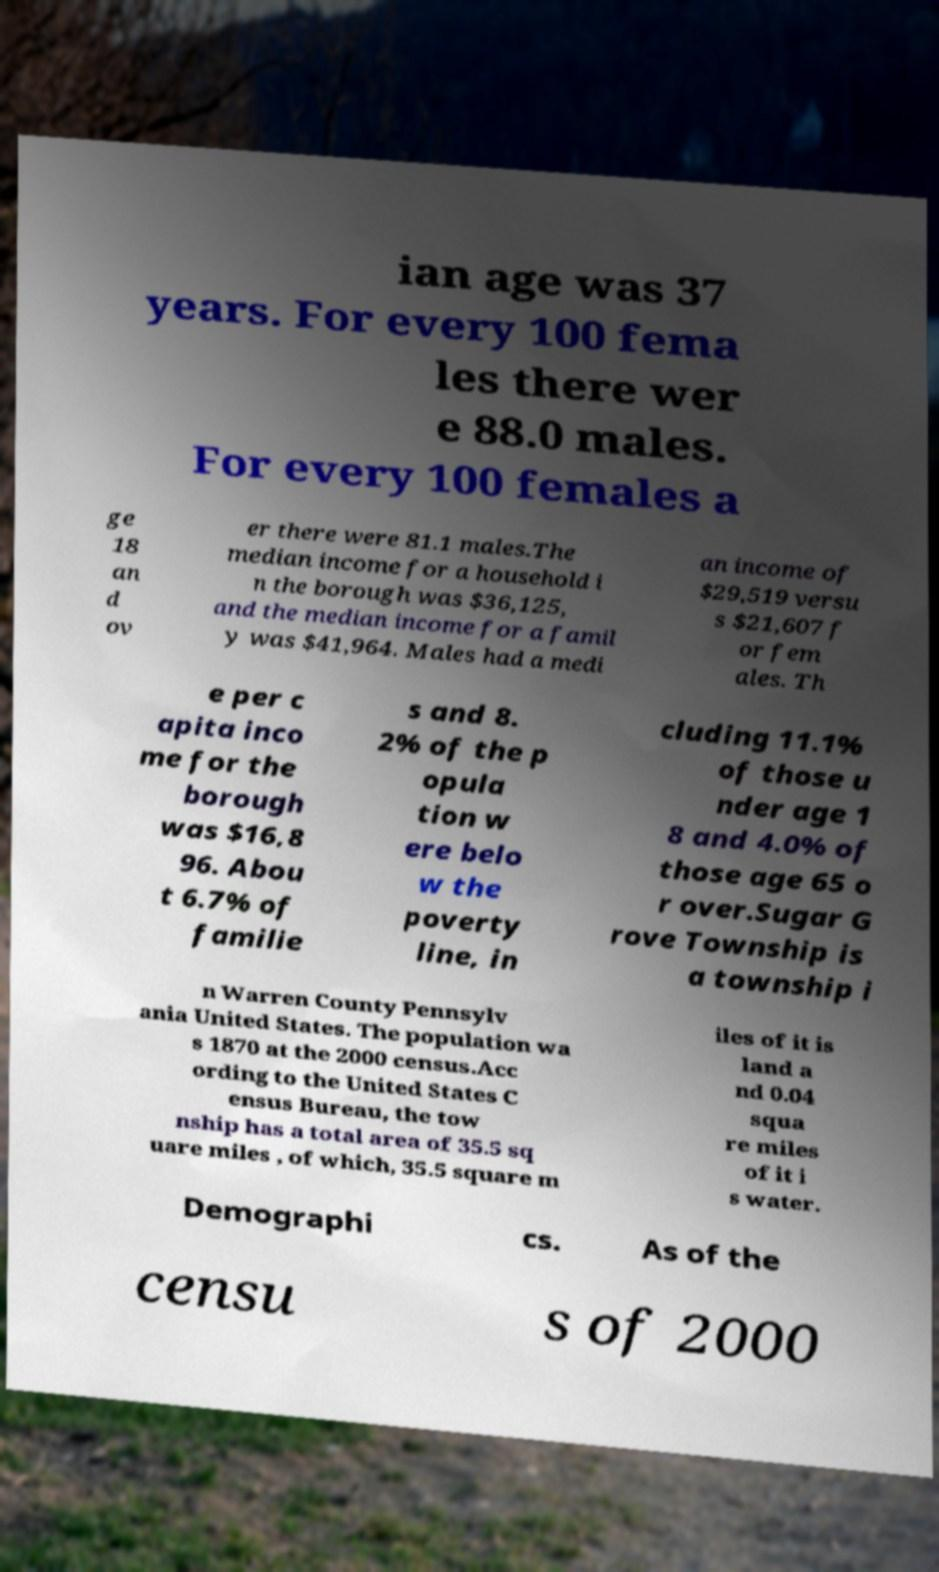There's text embedded in this image that I need extracted. Can you transcribe it verbatim? ian age was 37 years. For every 100 fema les there wer e 88.0 males. For every 100 females a ge 18 an d ov er there were 81.1 males.The median income for a household i n the borough was $36,125, and the median income for a famil y was $41,964. Males had a medi an income of $29,519 versu s $21,607 f or fem ales. Th e per c apita inco me for the borough was $16,8 96. Abou t 6.7% of familie s and 8. 2% of the p opula tion w ere belo w the poverty line, in cluding 11.1% of those u nder age 1 8 and 4.0% of those age 65 o r over.Sugar G rove Township is a township i n Warren County Pennsylv ania United States. The population wa s 1870 at the 2000 census.Acc ording to the United States C ensus Bureau, the tow nship has a total area of 35.5 sq uare miles , of which, 35.5 square m iles of it is land a nd 0.04 squa re miles of it i s water. Demographi cs. As of the censu s of 2000 